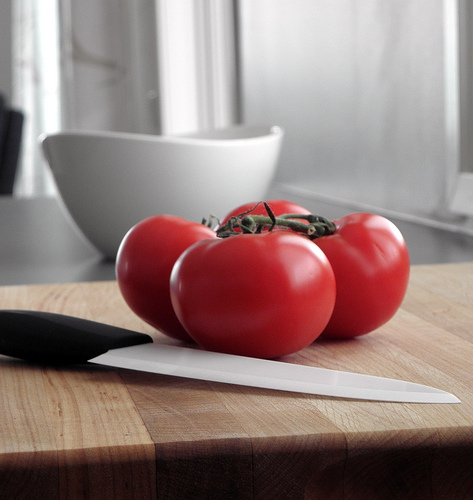<image>
Is the knife under the tomatoes? Yes. The knife is positioned underneath the tomatoes, with the tomatoes above it in the vertical space. Is the tomato in the bowl? No. The tomato is not contained within the bowl. These objects have a different spatial relationship. 